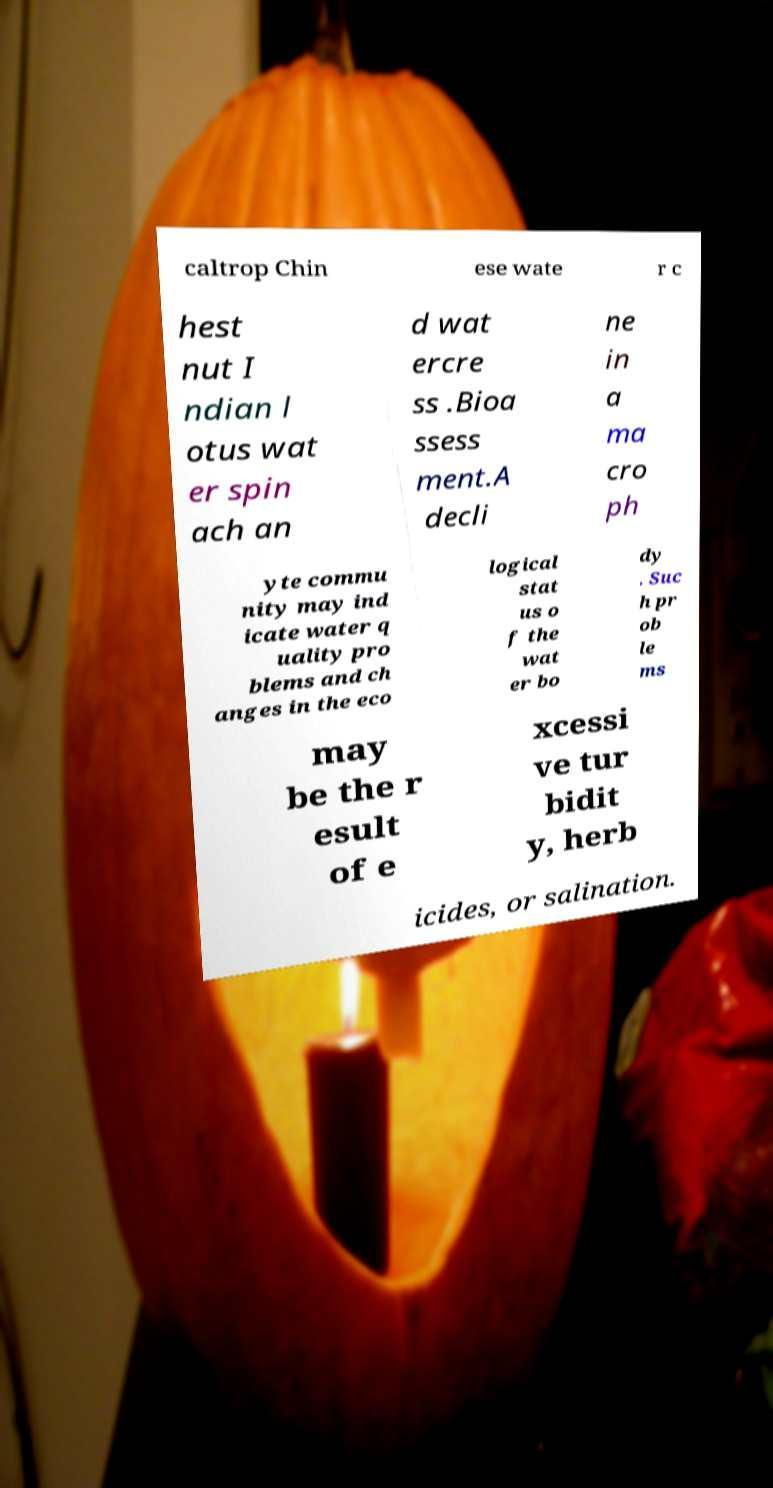There's text embedded in this image that I need extracted. Can you transcribe it verbatim? caltrop Chin ese wate r c hest nut I ndian l otus wat er spin ach an d wat ercre ss .Bioa ssess ment.A decli ne in a ma cro ph yte commu nity may ind icate water q uality pro blems and ch anges in the eco logical stat us o f the wat er bo dy . Suc h pr ob le ms may be the r esult of e xcessi ve tur bidit y, herb icides, or salination. 